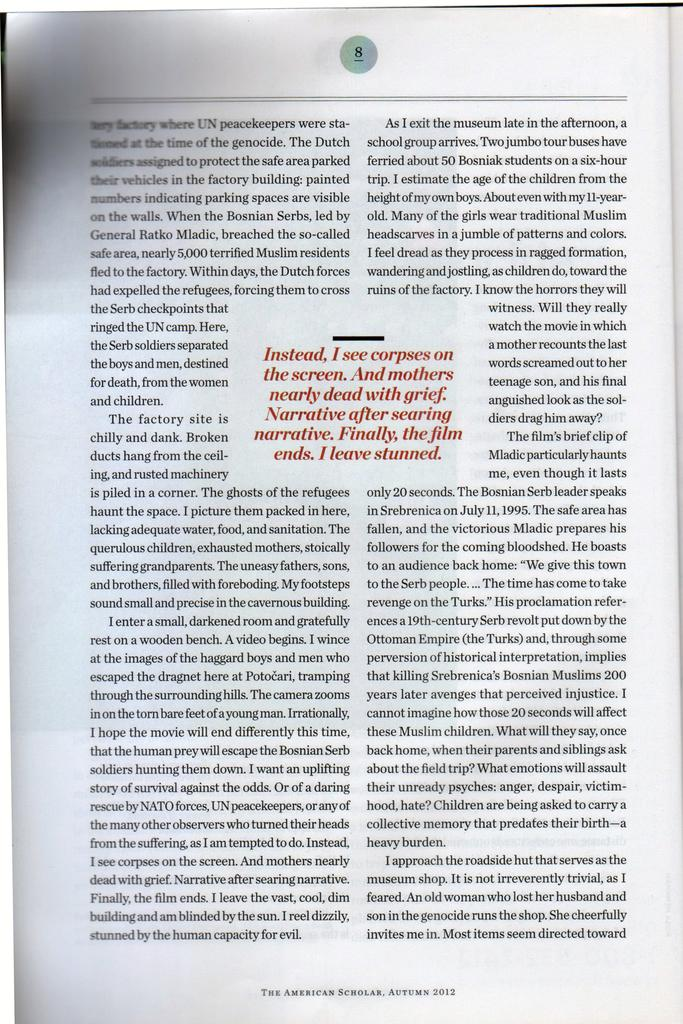<image>
Write a terse but informative summary of the picture. Page 8 of Autumn 2012 edition of The American Scholar. 